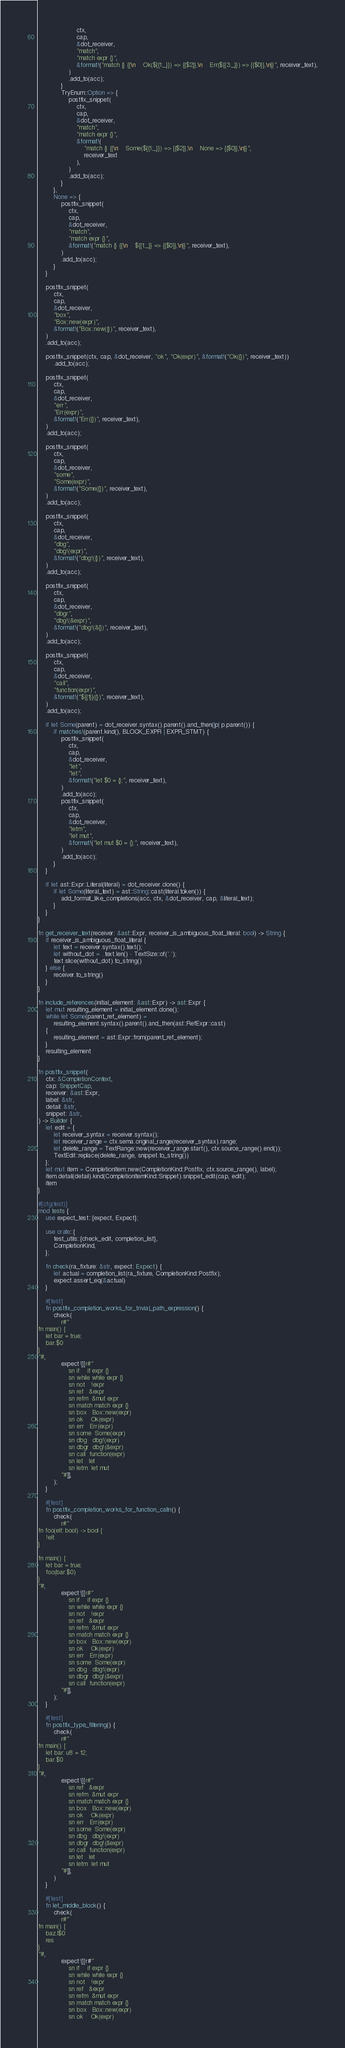<code> <loc_0><loc_0><loc_500><loc_500><_Rust_>                    ctx,
                    cap,
                    &dot_receiver,
                    "match",
                    "match expr {}",
                    &format!("match {} {{\n    Ok(${{1:_}}) => {{$2}},\n    Err(${{3:_}}) => {{$0}},\n}}", receiver_text),
                )
                .add_to(acc);
            }
            TryEnum::Option => {
                postfix_snippet(
                    ctx,
                    cap,
                    &dot_receiver,
                    "match",
                    "match expr {}",
                    &format!(
                        "match {} {{\n    Some(${{1:_}}) => {{$2}},\n    None => {{$0}},\n}}",
                        receiver_text
                    ),
                )
                .add_to(acc);
            }
        },
        None => {
            postfix_snippet(
                ctx,
                cap,
                &dot_receiver,
                "match",
                "match expr {}",
                &format!("match {} {{\n    ${{1:_}} => {{$0}},\n}}", receiver_text),
            )
            .add_to(acc);
        }
    }

    postfix_snippet(
        ctx,
        cap,
        &dot_receiver,
        "box",
        "Box::new(expr)",
        &format!("Box::new({})", receiver_text),
    )
    .add_to(acc);

    postfix_snippet(ctx, cap, &dot_receiver, "ok", "Ok(expr)", &format!("Ok({})", receiver_text))
        .add_to(acc);

    postfix_snippet(
        ctx,
        cap,
        &dot_receiver,
        "err",
        "Err(expr)",
        &format!("Err({})", receiver_text),
    )
    .add_to(acc);

    postfix_snippet(
        ctx,
        cap,
        &dot_receiver,
        "some",
        "Some(expr)",
        &format!("Some({})", receiver_text),
    )
    .add_to(acc);

    postfix_snippet(
        ctx,
        cap,
        &dot_receiver,
        "dbg",
        "dbg!(expr)",
        &format!("dbg!({})", receiver_text),
    )
    .add_to(acc);

    postfix_snippet(
        ctx,
        cap,
        &dot_receiver,
        "dbgr",
        "dbg!(&expr)",
        &format!("dbg!(&{})", receiver_text),
    )
    .add_to(acc);

    postfix_snippet(
        ctx,
        cap,
        &dot_receiver,
        "call",
        "function(expr)",
        &format!("${{1}}({})", receiver_text),
    )
    .add_to(acc);

    if let Some(parent) = dot_receiver.syntax().parent().and_then(|p| p.parent()) {
        if matches!(parent.kind(), BLOCK_EXPR | EXPR_STMT) {
            postfix_snippet(
                ctx,
                cap,
                &dot_receiver,
                "let",
                "let",
                &format!("let $0 = {};", receiver_text),
            )
            .add_to(acc);
            postfix_snippet(
                ctx,
                cap,
                &dot_receiver,
                "letm",
                "let mut",
                &format!("let mut $0 = {};", receiver_text),
            )
            .add_to(acc);
        }
    }

    if let ast::Expr::Literal(literal) = dot_receiver.clone() {
        if let Some(literal_text) = ast::String::cast(literal.token()) {
            add_format_like_completions(acc, ctx, &dot_receiver, cap, &literal_text);
        }
    }
}

fn get_receiver_text(receiver: &ast::Expr, receiver_is_ambiguous_float_literal: bool) -> String {
    if receiver_is_ambiguous_float_literal {
        let text = receiver.syntax().text();
        let without_dot = ..text.len() - TextSize::of('.');
        text.slice(without_dot).to_string()
    } else {
        receiver.to_string()
    }
}

fn include_references(initial_element: &ast::Expr) -> ast::Expr {
    let mut resulting_element = initial_element.clone();
    while let Some(parent_ref_element) =
        resulting_element.syntax().parent().and_then(ast::RefExpr::cast)
    {
        resulting_element = ast::Expr::from(parent_ref_element);
    }
    resulting_element
}

fn postfix_snippet(
    ctx: &CompletionContext,
    cap: SnippetCap,
    receiver: &ast::Expr,
    label: &str,
    detail: &str,
    snippet: &str,
) -> Builder {
    let edit = {
        let receiver_syntax = receiver.syntax();
        let receiver_range = ctx.sema.original_range(receiver_syntax).range;
        let delete_range = TextRange::new(receiver_range.start(), ctx.source_range().end());
        TextEdit::replace(delete_range, snippet.to_string())
    };
    let mut item = CompletionItem::new(CompletionKind::Postfix, ctx.source_range(), label);
    item.detail(detail).kind(CompletionItemKind::Snippet).snippet_edit(cap, edit);
    item
}

#[cfg(test)]
mod tests {
    use expect_test::{expect, Expect};

    use crate::{
        test_utils::{check_edit, completion_list},
        CompletionKind,
    };

    fn check(ra_fixture: &str, expect: Expect) {
        let actual = completion_list(ra_fixture, CompletionKind::Postfix);
        expect.assert_eq(&actual)
    }

    #[test]
    fn postfix_completion_works_for_trivial_path_expression() {
        check(
            r#"
fn main() {
    let bar = true;
    bar.$0
}
"#,
            expect![[r#"
                sn if    if expr {}
                sn while while expr {}
                sn not   !expr
                sn ref   &expr
                sn refm  &mut expr
                sn match match expr {}
                sn box   Box::new(expr)
                sn ok    Ok(expr)
                sn err   Err(expr)
                sn some  Some(expr)
                sn dbg   dbg!(expr)
                sn dbgr  dbg!(&expr)
                sn call  function(expr)
                sn let   let
                sn letm  let mut
            "#]],
        );
    }

    #[test]
    fn postfix_completion_works_for_function_calln() {
        check(
            r#"
fn foo(elt: bool) -> bool {
    !elt
}

fn main() {
    let bar = true;
    foo(bar.$0)
}
"#,
            expect![[r#"
                sn if    if expr {}
                sn while while expr {}
                sn not   !expr
                sn ref   &expr
                sn refm  &mut expr
                sn match match expr {}
                sn box   Box::new(expr)
                sn ok    Ok(expr)
                sn err   Err(expr)
                sn some  Some(expr)
                sn dbg   dbg!(expr)
                sn dbgr  dbg!(&expr)
                sn call  function(expr)
            "#]],
        );
    }

    #[test]
    fn postfix_type_filtering() {
        check(
            r#"
fn main() {
    let bar: u8 = 12;
    bar.$0
}
"#,
            expect![[r#"
                sn ref   &expr
                sn refm  &mut expr
                sn match match expr {}
                sn box   Box::new(expr)
                sn ok    Ok(expr)
                sn err   Err(expr)
                sn some  Some(expr)
                sn dbg   dbg!(expr)
                sn dbgr  dbg!(&expr)
                sn call  function(expr)
                sn let   let
                sn letm  let mut
            "#]],
        )
    }

    #[test]
    fn let_middle_block() {
        check(
            r#"
fn main() {
    baz.l$0
    res
}
"#,
            expect![[r#"
                sn if    if expr {}
                sn while while expr {}
                sn not   !expr
                sn ref   &expr
                sn refm  &mut expr
                sn match match expr {}
                sn box   Box::new(expr)
                sn ok    Ok(expr)</code> 